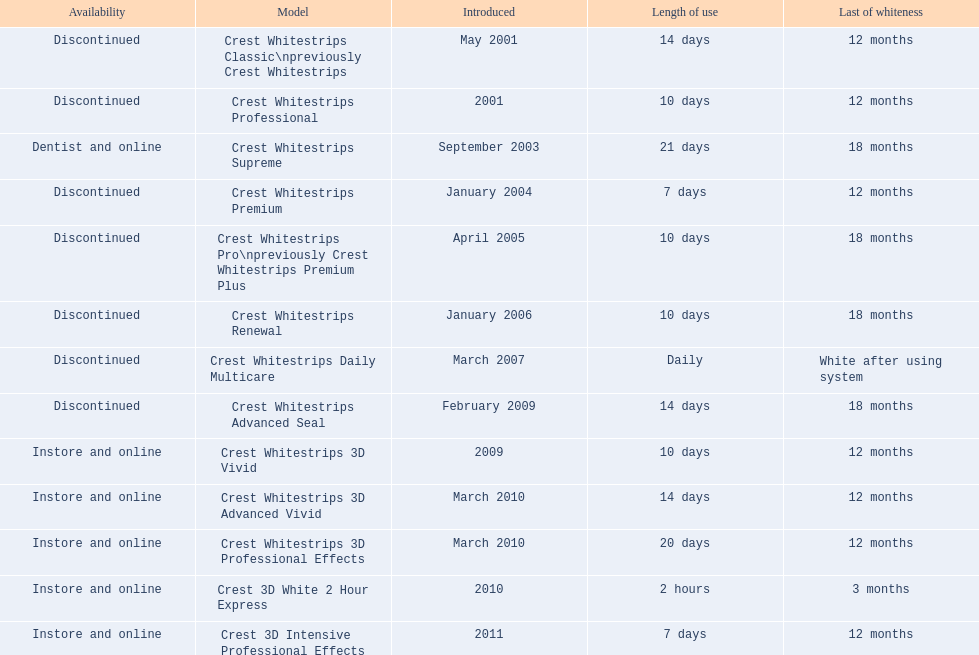What are all the models? Crest Whitestrips Classic\npreviously Crest Whitestrips, Crest Whitestrips Professional, Crest Whitestrips Supreme, Crest Whitestrips Premium, Crest Whitestrips Pro\npreviously Crest Whitestrips Premium Plus, Crest Whitestrips Renewal, Crest Whitestrips Daily Multicare, Crest Whitestrips Advanced Seal, Crest Whitestrips 3D Vivid, Crest Whitestrips 3D Advanced Vivid, Crest Whitestrips 3D Professional Effects, Crest 3D White 2 Hour Express, Crest 3D Intensive Professional Effects. Of these, for which can a ratio be calculated for 'length of use' to 'last of whiteness'? Crest Whitestrips Classic\npreviously Crest Whitestrips, Crest Whitestrips Professional, Crest Whitestrips Supreme, Crest Whitestrips Premium, Crest Whitestrips Pro\npreviously Crest Whitestrips Premium Plus, Crest Whitestrips Renewal, Crest Whitestrips Advanced Seal, Crest Whitestrips 3D Vivid, Crest Whitestrips 3D Advanced Vivid, Crest Whitestrips 3D Professional Effects, Crest 3D White 2 Hour Express, Crest 3D Intensive Professional Effects. Which has the highest ratio? Crest Whitestrips Supreme. 